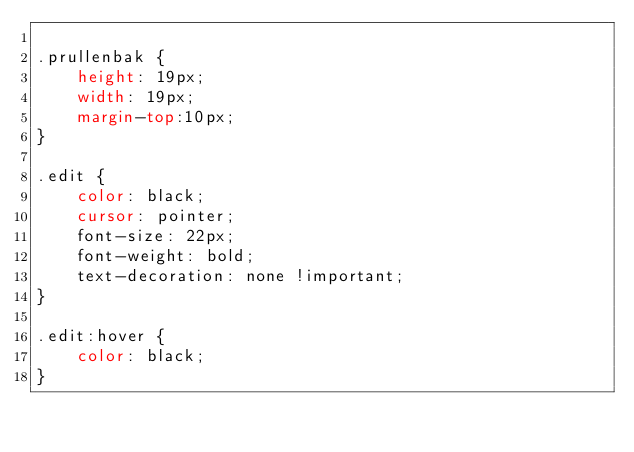Convert code to text. <code><loc_0><loc_0><loc_500><loc_500><_CSS_>
.prullenbak {
    height: 19px;
    width: 19px;
    margin-top:10px;
}

.edit {
    color: black;
    cursor: pointer;
    font-size: 22px;
    font-weight: bold;
    text-decoration: none !important;
}

.edit:hover {
    color: black;
}
</code> 